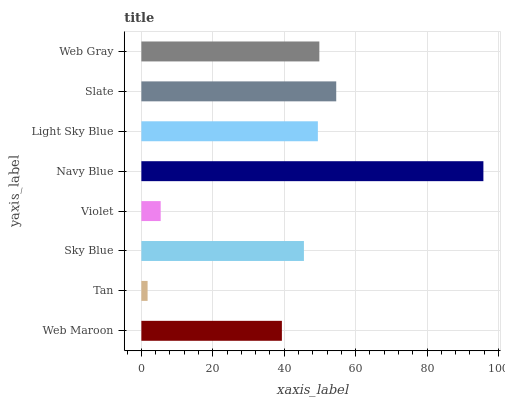Is Tan the minimum?
Answer yes or no. Yes. Is Navy Blue the maximum?
Answer yes or no. Yes. Is Sky Blue the minimum?
Answer yes or no. No. Is Sky Blue the maximum?
Answer yes or no. No. Is Sky Blue greater than Tan?
Answer yes or no. Yes. Is Tan less than Sky Blue?
Answer yes or no. Yes. Is Tan greater than Sky Blue?
Answer yes or no. No. Is Sky Blue less than Tan?
Answer yes or no. No. Is Light Sky Blue the high median?
Answer yes or no. Yes. Is Sky Blue the low median?
Answer yes or no. Yes. Is Tan the high median?
Answer yes or no. No. Is Violet the low median?
Answer yes or no. No. 